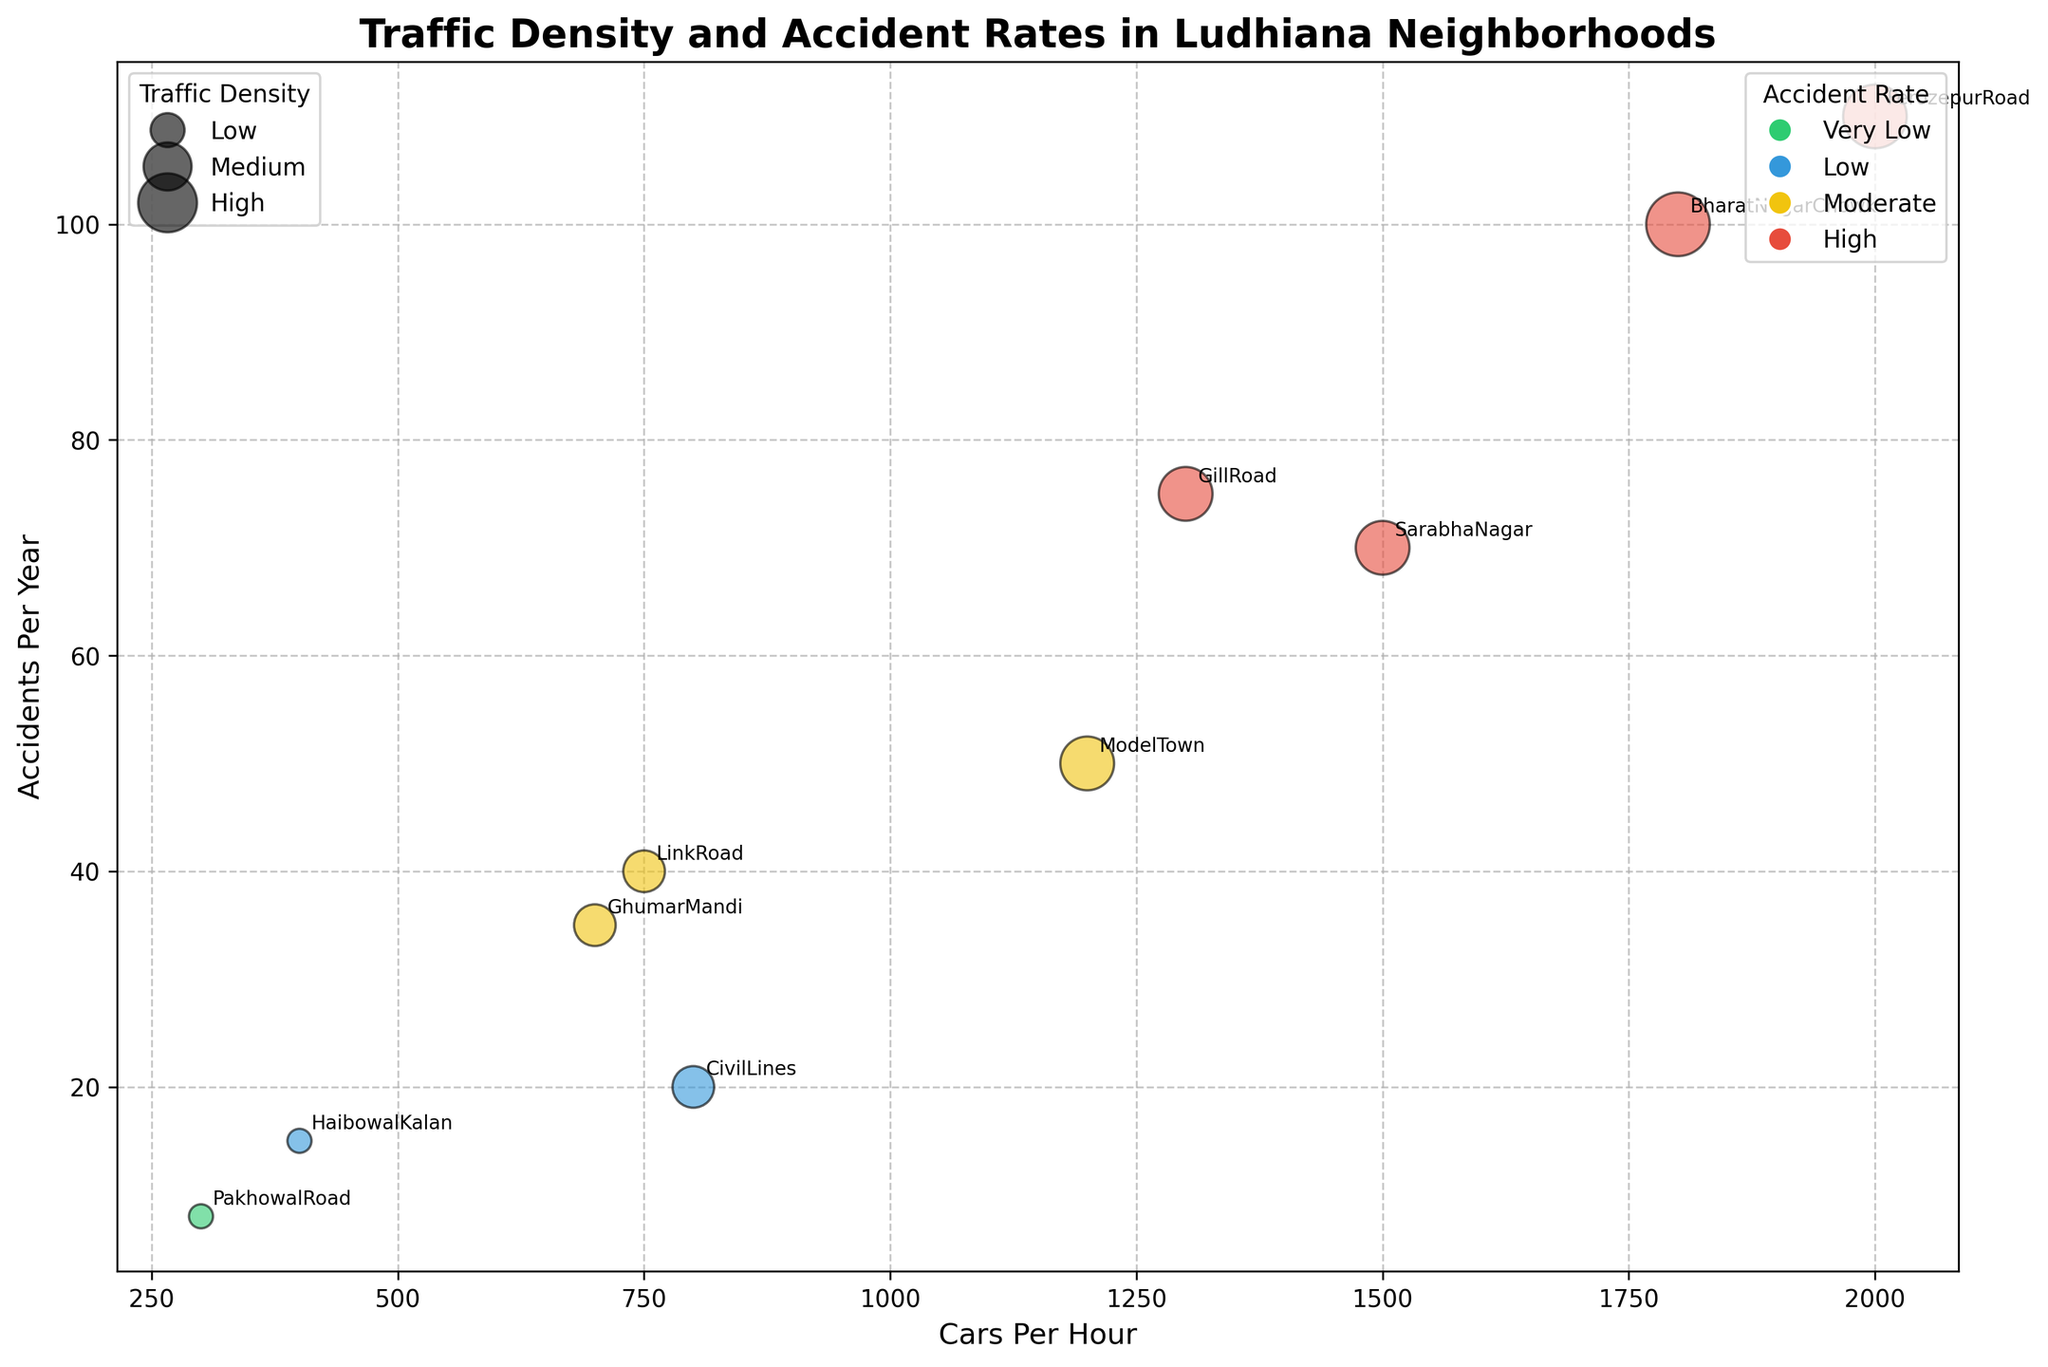Which neighborhood has the highest number of accidents per year? First, look at the y-axis representing "Accidents Per Year". Identify the highest data point on this axis. The largest value of 110 corresponds to the "Ferozepur Road" neighborhood based on the annotation.
Answer: Ferozepur Road Which neighborhood has the highest traffic density? The size of the bubbles indicates the traffic density. The largest bubbles correspond to "Very High" traffic density. "Bharat Nagar Chowk" and "Ferozepur Road" have the largest bubble sizes.
Answer: Bharat Nagar Chowk and Ferozepur Road What is the color representing moderate accident rates? To find this, look at the legend on the right side of the plot which shows accident rates. The color for "Moderate" accident rates is yellow.
Answer: Yellow How many neighborhoods have a high accident rate? Look for red-colored bubbles which indicate a high accident rate. There are four red-colored bubbles corresponding to "Sarabha Nagar", "Gill Road", "Bharat Nagar Chowk", and "Ferozepur Road".
Answer: 4 Comparing Sarabha Nagar and Haibowal Kalan, which neighborhood has a higher number of accidents per year and by how much? First, identify the y-values of "Sarabha Nagar" and "Haibowal Kalan" which show accidents per year. "Sarabha Nagar" has 70 and "Haibowal Kalan" has 15. The difference is 70 - 15 = 55.
Answer: Sarabha Nagar by 55 Which neighborhood has the lowest traffic density and what is its accident rate? The size of the bubbles indicates traffic density. The smallest bubble corresponds to "Pakhowal Road" which has the lowest (very low) traffic density. Its color is green, indicating a "Very Low" accident rate.
Answer: Pakhowal Road, Very Low Approximately how many cars per hour are there in Civil Lines compared to Sarabha Nagar? Look at the x-axis values of "Cars Per Hour" for both neighborhoods. "Civil Lines" has 800 cars per hour and "Sarabha Nagar" has 1500 cars per hour. Subtracting gives 1500 - 800 = 700.
Answer: Sarabha Nagar has 700 more cars per hour What color represents neighborhoods with low accident rates? Check the legend on the right side of the plot that shows accident rates. The color for "Low" accident rates is blue.
Answer: Blue Which two neighborhoods have the highest traffic densities based on the bubble size and accident rate color? Identify the largest bubbles which indicate very high traffic density. "Bharat Nagar Chowk" and "Ferozepur Road" both show big bubbles and are colored red, indicating a high accident rate.
Answer: Bharat Nagar Chowk and Ferozepur Road 